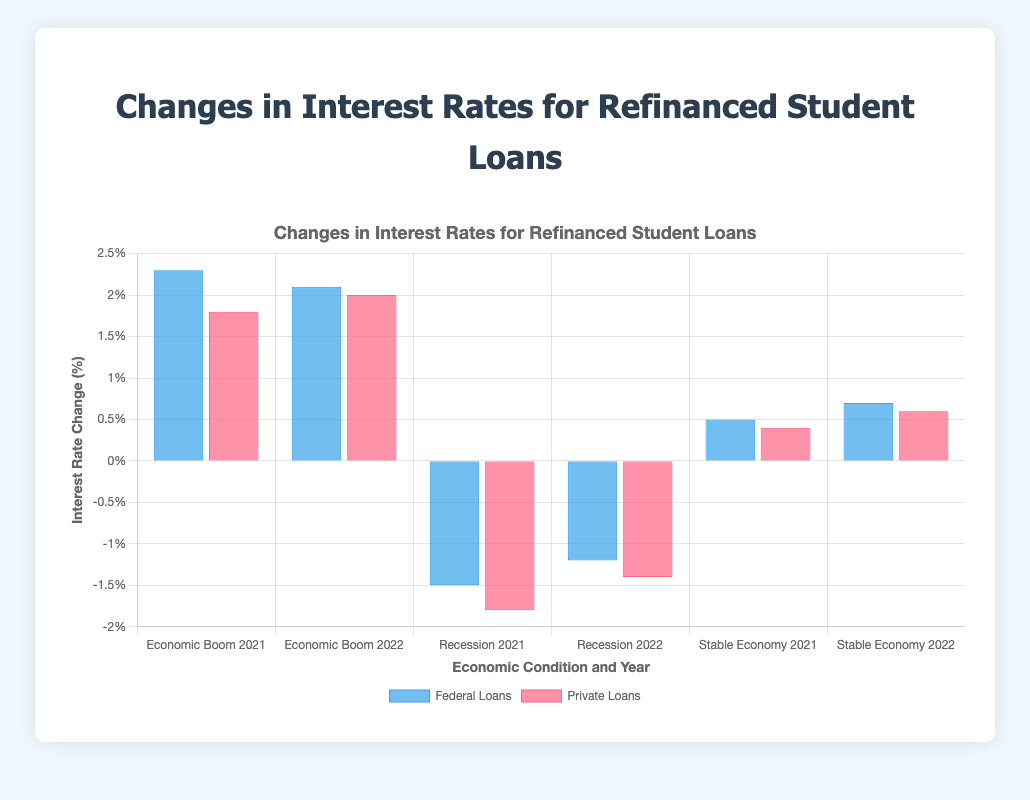Which original loan type had a higher interest rate increase during the Economic Boom in 2021? To determine the original loan type with a higher increase, compare the bar heights for Federal and Private Loans under "Economic Boom 2021". The Federal Loans bar is higher at 2.3%, while the Private Loans bar is at 1.8%.
Answer: Federal Loans During the Recession in 2022, which loan type saw less of a reduction in interest rates? Compare the bars for Federal and Private Loans under "Recession 2022". The Federal Loans bar shows -1.2% and the Private Loans bar shows -1.4%. Federal Loans experienced a smaller reduction.
Answer: Federal Loans What's the difference in interest rate changes for Federal Loans between Economic Boom in 2021 and Recession in 2021? Subtract the interest rate change during Recession from the change during Economic Boom (2.3% - (-1.5%) = 2.3% + 1.5% = 3.8%). The difference is 3.8%.
Answer: 3.8% Which economic condition resulted in the highest increase in interest rates for either loan type in 2022? Compare the bar heights for 2022 under each condition. The highest bar in 2022 is for Private Loans during the Economic Boom at 2.0%.
Answer: Economic Boom What is the average interest rate change for Private Loans across all economic conditions in 2021? Add the interest rate changes for Private Loans in 2021 and divide by 3 (1.8% + (-1.8%) + 0.4%) / 3 = 0.4%, -1.8% + 1.8% cancels out, leaving 0.4%.
Answer: -0.2/3= 0 Which economic condition had the smallest absolute change in interest rates for Federal Loans in 2021? Compare the absolute values of interest rate changes for Federal Loans in 2021. Economic Boom is 2.3%, Recession is 1.5%, and Stable Economy is 0.5%. The smallest absolute change is 0.5% under Stable Economy.
Answer: Stable Economy Is the interest rate change for Federal Loans in 2022 higher or lower than in 2021 under a Stable Economy? Compare the bar heights for Federal Loans under "Stable Economy 2021" and "Stable Economy 2022". The bar is higher in 2022 (0.7%) than in 2021 (0.5%).
Answer: Higher What is the net change in interest rates for Private Loans during Recession from 2021 to 2022? Subtract the 2021 value from the 2022 value (-1.4% - (-1.8%) = -1.4% + 1.8% = 0.4%). The net change is 0.4%.
Answer: 0.4% During an Economic Boom, by how much did the interest rate change for Private Loans differ between 2021 and 2022? Calculate the difference by subtracting the 2021 value from the 2022 value (2.0% - 1.8% = 0.2%). The difference is 0.2%.
Answer: 0.2% 